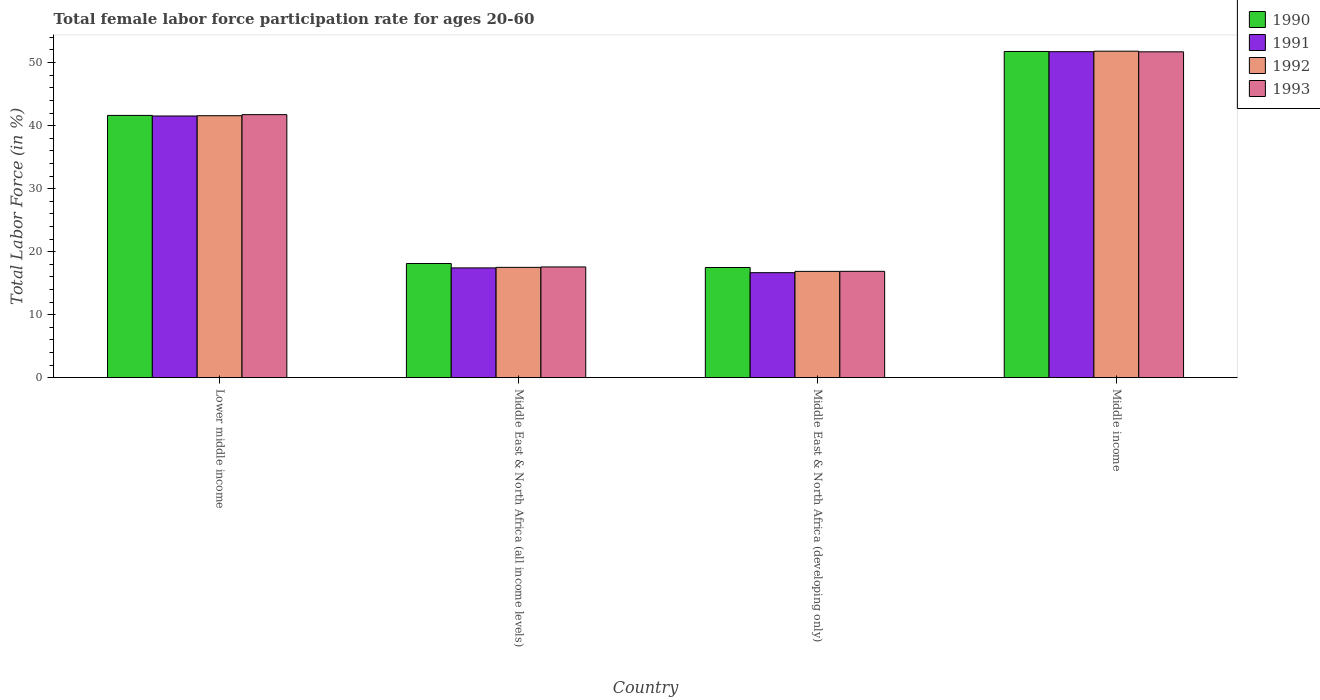How many different coloured bars are there?
Your answer should be very brief. 4. Are the number of bars per tick equal to the number of legend labels?
Give a very brief answer. Yes. How many bars are there on the 1st tick from the left?
Provide a succinct answer. 4. What is the label of the 3rd group of bars from the left?
Offer a very short reply. Middle East & North Africa (developing only). In how many cases, is the number of bars for a given country not equal to the number of legend labels?
Your response must be concise. 0. What is the female labor force participation rate in 1993 in Middle East & North Africa (all income levels)?
Your response must be concise. 17.57. Across all countries, what is the maximum female labor force participation rate in 1993?
Your answer should be compact. 51.71. Across all countries, what is the minimum female labor force participation rate in 1991?
Your response must be concise. 16.66. In which country was the female labor force participation rate in 1993 maximum?
Offer a terse response. Middle income. In which country was the female labor force participation rate in 1993 minimum?
Offer a terse response. Middle East & North Africa (developing only). What is the total female labor force participation rate in 1990 in the graph?
Offer a very short reply. 128.98. What is the difference between the female labor force participation rate in 1991 in Lower middle income and that in Middle East & North Africa (developing only)?
Your answer should be very brief. 24.87. What is the difference between the female labor force participation rate in 1992 in Middle East & North Africa (all income levels) and the female labor force participation rate in 1990 in Middle income?
Keep it short and to the point. -34.26. What is the average female labor force participation rate in 1993 per country?
Offer a terse response. 31.97. What is the difference between the female labor force participation rate of/in 1991 and female labor force participation rate of/in 1992 in Middle East & North Africa (developing only)?
Your response must be concise. -0.21. What is the ratio of the female labor force participation rate in 1993 in Middle East & North Africa (all income levels) to that in Middle income?
Ensure brevity in your answer.  0.34. Is the difference between the female labor force participation rate in 1991 in Middle East & North Africa (developing only) and Middle income greater than the difference between the female labor force participation rate in 1992 in Middle East & North Africa (developing only) and Middle income?
Your answer should be very brief. No. What is the difference between the highest and the second highest female labor force participation rate in 1990?
Give a very brief answer. 23.5. What is the difference between the highest and the lowest female labor force participation rate in 1991?
Keep it short and to the point. 35.07. Is the sum of the female labor force participation rate in 1990 in Lower middle income and Middle East & North Africa (all income levels) greater than the maximum female labor force participation rate in 1992 across all countries?
Give a very brief answer. Yes. What does the 1st bar from the right in Lower middle income represents?
Your answer should be very brief. 1993. Is it the case that in every country, the sum of the female labor force participation rate in 1991 and female labor force participation rate in 1993 is greater than the female labor force participation rate in 1992?
Provide a short and direct response. Yes. Are all the bars in the graph horizontal?
Your answer should be compact. No. What is the difference between two consecutive major ticks on the Y-axis?
Ensure brevity in your answer.  10. Does the graph contain grids?
Offer a very short reply. No. Where does the legend appear in the graph?
Provide a succinct answer. Top right. How are the legend labels stacked?
Keep it short and to the point. Vertical. What is the title of the graph?
Ensure brevity in your answer.  Total female labor force participation rate for ages 20-60. What is the label or title of the X-axis?
Make the answer very short. Country. What is the Total Labor Force (in %) of 1990 in Lower middle income?
Make the answer very short. 41.62. What is the Total Labor Force (in %) in 1991 in Lower middle income?
Give a very brief answer. 41.53. What is the Total Labor Force (in %) in 1992 in Lower middle income?
Keep it short and to the point. 41.57. What is the Total Labor Force (in %) of 1993 in Lower middle income?
Keep it short and to the point. 41.74. What is the Total Labor Force (in %) of 1990 in Middle East & North Africa (all income levels)?
Your response must be concise. 18.11. What is the Total Labor Force (in %) in 1991 in Middle East & North Africa (all income levels)?
Provide a short and direct response. 17.42. What is the Total Labor Force (in %) in 1992 in Middle East & North Africa (all income levels)?
Offer a terse response. 17.5. What is the Total Labor Force (in %) in 1993 in Middle East & North Africa (all income levels)?
Keep it short and to the point. 17.57. What is the Total Labor Force (in %) in 1990 in Middle East & North Africa (developing only)?
Offer a terse response. 17.48. What is the Total Labor Force (in %) of 1991 in Middle East & North Africa (developing only)?
Make the answer very short. 16.66. What is the Total Labor Force (in %) of 1992 in Middle East & North Africa (developing only)?
Provide a short and direct response. 16.87. What is the Total Labor Force (in %) of 1993 in Middle East & North Africa (developing only)?
Provide a short and direct response. 16.88. What is the Total Labor Force (in %) in 1990 in Middle income?
Your response must be concise. 51.76. What is the Total Labor Force (in %) in 1991 in Middle income?
Provide a succinct answer. 51.73. What is the Total Labor Force (in %) of 1992 in Middle income?
Your answer should be compact. 51.81. What is the Total Labor Force (in %) in 1993 in Middle income?
Provide a short and direct response. 51.71. Across all countries, what is the maximum Total Labor Force (in %) in 1990?
Make the answer very short. 51.76. Across all countries, what is the maximum Total Labor Force (in %) of 1991?
Make the answer very short. 51.73. Across all countries, what is the maximum Total Labor Force (in %) in 1992?
Your answer should be compact. 51.81. Across all countries, what is the maximum Total Labor Force (in %) of 1993?
Provide a short and direct response. 51.71. Across all countries, what is the minimum Total Labor Force (in %) of 1990?
Your response must be concise. 17.48. Across all countries, what is the minimum Total Labor Force (in %) of 1991?
Your answer should be very brief. 16.66. Across all countries, what is the minimum Total Labor Force (in %) of 1992?
Offer a very short reply. 16.87. Across all countries, what is the minimum Total Labor Force (in %) of 1993?
Provide a short and direct response. 16.88. What is the total Total Labor Force (in %) of 1990 in the graph?
Offer a terse response. 128.98. What is the total Total Labor Force (in %) in 1991 in the graph?
Keep it short and to the point. 127.34. What is the total Total Labor Force (in %) in 1992 in the graph?
Give a very brief answer. 127.75. What is the total Total Labor Force (in %) of 1993 in the graph?
Give a very brief answer. 127.9. What is the difference between the Total Labor Force (in %) of 1990 in Lower middle income and that in Middle East & North Africa (all income levels)?
Offer a very short reply. 23.5. What is the difference between the Total Labor Force (in %) of 1991 in Lower middle income and that in Middle East & North Africa (all income levels)?
Provide a succinct answer. 24.11. What is the difference between the Total Labor Force (in %) of 1992 in Lower middle income and that in Middle East & North Africa (all income levels)?
Offer a very short reply. 24.07. What is the difference between the Total Labor Force (in %) in 1993 in Lower middle income and that in Middle East & North Africa (all income levels)?
Provide a succinct answer. 24.17. What is the difference between the Total Labor Force (in %) of 1990 in Lower middle income and that in Middle East & North Africa (developing only)?
Make the answer very short. 24.14. What is the difference between the Total Labor Force (in %) in 1991 in Lower middle income and that in Middle East & North Africa (developing only)?
Provide a succinct answer. 24.87. What is the difference between the Total Labor Force (in %) of 1992 in Lower middle income and that in Middle East & North Africa (developing only)?
Make the answer very short. 24.7. What is the difference between the Total Labor Force (in %) in 1993 in Lower middle income and that in Middle East & North Africa (developing only)?
Your answer should be compact. 24.86. What is the difference between the Total Labor Force (in %) in 1990 in Lower middle income and that in Middle income?
Make the answer very short. -10.15. What is the difference between the Total Labor Force (in %) in 1991 in Lower middle income and that in Middle income?
Your answer should be very brief. -10.21. What is the difference between the Total Labor Force (in %) in 1992 in Lower middle income and that in Middle income?
Your answer should be very brief. -10.24. What is the difference between the Total Labor Force (in %) in 1993 in Lower middle income and that in Middle income?
Offer a terse response. -9.97. What is the difference between the Total Labor Force (in %) in 1990 in Middle East & North Africa (all income levels) and that in Middle East & North Africa (developing only)?
Your response must be concise. 0.63. What is the difference between the Total Labor Force (in %) of 1991 in Middle East & North Africa (all income levels) and that in Middle East & North Africa (developing only)?
Provide a short and direct response. 0.76. What is the difference between the Total Labor Force (in %) of 1992 in Middle East & North Africa (all income levels) and that in Middle East & North Africa (developing only)?
Your answer should be very brief. 0.64. What is the difference between the Total Labor Force (in %) in 1993 in Middle East & North Africa (all income levels) and that in Middle East & North Africa (developing only)?
Offer a terse response. 0.69. What is the difference between the Total Labor Force (in %) in 1990 in Middle East & North Africa (all income levels) and that in Middle income?
Ensure brevity in your answer.  -33.65. What is the difference between the Total Labor Force (in %) of 1991 in Middle East & North Africa (all income levels) and that in Middle income?
Your answer should be compact. -34.31. What is the difference between the Total Labor Force (in %) in 1992 in Middle East & North Africa (all income levels) and that in Middle income?
Ensure brevity in your answer.  -34.31. What is the difference between the Total Labor Force (in %) in 1993 in Middle East & North Africa (all income levels) and that in Middle income?
Your answer should be very brief. -34.14. What is the difference between the Total Labor Force (in %) of 1990 in Middle East & North Africa (developing only) and that in Middle income?
Keep it short and to the point. -34.28. What is the difference between the Total Labor Force (in %) in 1991 in Middle East & North Africa (developing only) and that in Middle income?
Your answer should be very brief. -35.07. What is the difference between the Total Labor Force (in %) of 1992 in Middle East & North Africa (developing only) and that in Middle income?
Your response must be concise. -34.94. What is the difference between the Total Labor Force (in %) in 1993 in Middle East & North Africa (developing only) and that in Middle income?
Ensure brevity in your answer.  -34.83. What is the difference between the Total Labor Force (in %) of 1990 in Lower middle income and the Total Labor Force (in %) of 1991 in Middle East & North Africa (all income levels)?
Your answer should be compact. 24.2. What is the difference between the Total Labor Force (in %) in 1990 in Lower middle income and the Total Labor Force (in %) in 1992 in Middle East & North Africa (all income levels)?
Your answer should be compact. 24.12. What is the difference between the Total Labor Force (in %) in 1990 in Lower middle income and the Total Labor Force (in %) in 1993 in Middle East & North Africa (all income levels)?
Your response must be concise. 24.05. What is the difference between the Total Labor Force (in %) of 1991 in Lower middle income and the Total Labor Force (in %) of 1992 in Middle East & North Africa (all income levels)?
Give a very brief answer. 24.02. What is the difference between the Total Labor Force (in %) of 1991 in Lower middle income and the Total Labor Force (in %) of 1993 in Middle East & North Africa (all income levels)?
Offer a very short reply. 23.95. What is the difference between the Total Labor Force (in %) of 1992 in Lower middle income and the Total Labor Force (in %) of 1993 in Middle East & North Africa (all income levels)?
Give a very brief answer. 24. What is the difference between the Total Labor Force (in %) of 1990 in Lower middle income and the Total Labor Force (in %) of 1991 in Middle East & North Africa (developing only)?
Your answer should be very brief. 24.96. What is the difference between the Total Labor Force (in %) in 1990 in Lower middle income and the Total Labor Force (in %) in 1992 in Middle East & North Africa (developing only)?
Provide a succinct answer. 24.75. What is the difference between the Total Labor Force (in %) of 1990 in Lower middle income and the Total Labor Force (in %) of 1993 in Middle East & North Africa (developing only)?
Your answer should be compact. 24.74. What is the difference between the Total Labor Force (in %) of 1991 in Lower middle income and the Total Labor Force (in %) of 1992 in Middle East & North Africa (developing only)?
Offer a terse response. 24.66. What is the difference between the Total Labor Force (in %) of 1991 in Lower middle income and the Total Labor Force (in %) of 1993 in Middle East & North Africa (developing only)?
Your answer should be compact. 24.65. What is the difference between the Total Labor Force (in %) of 1992 in Lower middle income and the Total Labor Force (in %) of 1993 in Middle East & North Africa (developing only)?
Keep it short and to the point. 24.69. What is the difference between the Total Labor Force (in %) in 1990 in Lower middle income and the Total Labor Force (in %) in 1991 in Middle income?
Offer a terse response. -10.11. What is the difference between the Total Labor Force (in %) in 1990 in Lower middle income and the Total Labor Force (in %) in 1992 in Middle income?
Offer a terse response. -10.19. What is the difference between the Total Labor Force (in %) of 1990 in Lower middle income and the Total Labor Force (in %) of 1993 in Middle income?
Ensure brevity in your answer.  -10.09. What is the difference between the Total Labor Force (in %) in 1991 in Lower middle income and the Total Labor Force (in %) in 1992 in Middle income?
Ensure brevity in your answer.  -10.28. What is the difference between the Total Labor Force (in %) of 1991 in Lower middle income and the Total Labor Force (in %) of 1993 in Middle income?
Your answer should be very brief. -10.18. What is the difference between the Total Labor Force (in %) in 1992 in Lower middle income and the Total Labor Force (in %) in 1993 in Middle income?
Offer a very short reply. -10.14. What is the difference between the Total Labor Force (in %) of 1990 in Middle East & North Africa (all income levels) and the Total Labor Force (in %) of 1991 in Middle East & North Africa (developing only)?
Provide a succinct answer. 1.45. What is the difference between the Total Labor Force (in %) of 1990 in Middle East & North Africa (all income levels) and the Total Labor Force (in %) of 1992 in Middle East & North Africa (developing only)?
Make the answer very short. 1.25. What is the difference between the Total Labor Force (in %) in 1990 in Middle East & North Africa (all income levels) and the Total Labor Force (in %) in 1993 in Middle East & North Africa (developing only)?
Give a very brief answer. 1.24. What is the difference between the Total Labor Force (in %) in 1991 in Middle East & North Africa (all income levels) and the Total Labor Force (in %) in 1992 in Middle East & North Africa (developing only)?
Offer a terse response. 0.55. What is the difference between the Total Labor Force (in %) of 1991 in Middle East & North Africa (all income levels) and the Total Labor Force (in %) of 1993 in Middle East & North Africa (developing only)?
Offer a terse response. 0.54. What is the difference between the Total Labor Force (in %) of 1992 in Middle East & North Africa (all income levels) and the Total Labor Force (in %) of 1993 in Middle East & North Africa (developing only)?
Make the answer very short. 0.63. What is the difference between the Total Labor Force (in %) in 1990 in Middle East & North Africa (all income levels) and the Total Labor Force (in %) in 1991 in Middle income?
Your answer should be very brief. -33.62. What is the difference between the Total Labor Force (in %) of 1990 in Middle East & North Africa (all income levels) and the Total Labor Force (in %) of 1992 in Middle income?
Keep it short and to the point. -33.7. What is the difference between the Total Labor Force (in %) of 1990 in Middle East & North Africa (all income levels) and the Total Labor Force (in %) of 1993 in Middle income?
Ensure brevity in your answer.  -33.6. What is the difference between the Total Labor Force (in %) of 1991 in Middle East & North Africa (all income levels) and the Total Labor Force (in %) of 1992 in Middle income?
Keep it short and to the point. -34.39. What is the difference between the Total Labor Force (in %) of 1991 in Middle East & North Africa (all income levels) and the Total Labor Force (in %) of 1993 in Middle income?
Your answer should be compact. -34.29. What is the difference between the Total Labor Force (in %) of 1992 in Middle East & North Africa (all income levels) and the Total Labor Force (in %) of 1993 in Middle income?
Your answer should be very brief. -34.21. What is the difference between the Total Labor Force (in %) in 1990 in Middle East & North Africa (developing only) and the Total Labor Force (in %) in 1991 in Middle income?
Your response must be concise. -34.25. What is the difference between the Total Labor Force (in %) in 1990 in Middle East & North Africa (developing only) and the Total Labor Force (in %) in 1992 in Middle income?
Your answer should be very brief. -34.33. What is the difference between the Total Labor Force (in %) in 1990 in Middle East & North Africa (developing only) and the Total Labor Force (in %) in 1993 in Middle income?
Your answer should be compact. -34.23. What is the difference between the Total Labor Force (in %) of 1991 in Middle East & North Africa (developing only) and the Total Labor Force (in %) of 1992 in Middle income?
Offer a very short reply. -35.15. What is the difference between the Total Labor Force (in %) in 1991 in Middle East & North Africa (developing only) and the Total Labor Force (in %) in 1993 in Middle income?
Provide a short and direct response. -35.05. What is the difference between the Total Labor Force (in %) in 1992 in Middle East & North Africa (developing only) and the Total Labor Force (in %) in 1993 in Middle income?
Your response must be concise. -34.84. What is the average Total Labor Force (in %) in 1990 per country?
Ensure brevity in your answer.  32.24. What is the average Total Labor Force (in %) of 1991 per country?
Offer a very short reply. 31.83. What is the average Total Labor Force (in %) of 1992 per country?
Provide a succinct answer. 31.94. What is the average Total Labor Force (in %) in 1993 per country?
Your answer should be very brief. 31.97. What is the difference between the Total Labor Force (in %) in 1990 and Total Labor Force (in %) in 1991 in Lower middle income?
Your response must be concise. 0.09. What is the difference between the Total Labor Force (in %) of 1990 and Total Labor Force (in %) of 1992 in Lower middle income?
Keep it short and to the point. 0.05. What is the difference between the Total Labor Force (in %) in 1990 and Total Labor Force (in %) in 1993 in Lower middle income?
Give a very brief answer. -0.12. What is the difference between the Total Labor Force (in %) of 1991 and Total Labor Force (in %) of 1992 in Lower middle income?
Ensure brevity in your answer.  -0.04. What is the difference between the Total Labor Force (in %) in 1991 and Total Labor Force (in %) in 1993 in Lower middle income?
Your answer should be very brief. -0.21. What is the difference between the Total Labor Force (in %) in 1992 and Total Labor Force (in %) in 1993 in Lower middle income?
Your answer should be very brief. -0.17. What is the difference between the Total Labor Force (in %) of 1990 and Total Labor Force (in %) of 1991 in Middle East & North Africa (all income levels)?
Provide a succinct answer. 0.69. What is the difference between the Total Labor Force (in %) in 1990 and Total Labor Force (in %) in 1992 in Middle East & North Africa (all income levels)?
Give a very brief answer. 0.61. What is the difference between the Total Labor Force (in %) of 1990 and Total Labor Force (in %) of 1993 in Middle East & North Africa (all income levels)?
Ensure brevity in your answer.  0.54. What is the difference between the Total Labor Force (in %) of 1991 and Total Labor Force (in %) of 1992 in Middle East & North Africa (all income levels)?
Make the answer very short. -0.08. What is the difference between the Total Labor Force (in %) of 1991 and Total Labor Force (in %) of 1993 in Middle East & North Africa (all income levels)?
Give a very brief answer. -0.15. What is the difference between the Total Labor Force (in %) of 1992 and Total Labor Force (in %) of 1993 in Middle East & North Africa (all income levels)?
Ensure brevity in your answer.  -0.07. What is the difference between the Total Labor Force (in %) in 1990 and Total Labor Force (in %) in 1991 in Middle East & North Africa (developing only)?
Your answer should be compact. 0.82. What is the difference between the Total Labor Force (in %) in 1990 and Total Labor Force (in %) in 1992 in Middle East & North Africa (developing only)?
Your answer should be compact. 0.62. What is the difference between the Total Labor Force (in %) of 1990 and Total Labor Force (in %) of 1993 in Middle East & North Africa (developing only)?
Your response must be concise. 0.61. What is the difference between the Total Labor Force (in %) of 1991 and Total Labor Force (in %) of 1992 in Middle East & North Africa (developing only)?
Provide a short and direct response. -0.21. What is the difference between the Total Labor Force (in %) in 1991 and Total Labor Force (in %) in 1993 in Middle East & North Africa (developing only)?
Keep it short and to the point. -0.22. What is the difference between the Total Labor Force (in %) of 1992 and Total Labor Force (in %) of 1993 in Middle East & North Africa (developing only)?
Provide a succinct answer. -0.01. What is the difference between the Total Labor Force (in %) of 1990 and Total Labor Force (in %) of 1991 in Middle income?
Your response must be concise. 0.03. What is the difference between the Total Labor Force (in %) in 1990 and Total Labor Force (in %) in 1992 in Middle income?
Keep it short and to the point. -0.05. What is the difference between the Total Labor Force (in %) of 1990 and Total Labor Force (in %) of 1993 in Middle income?
Your answer should be compact. 0.05. What is the difference between the Total Labor Force (in %) of 1991 and Total Labor Force (in %) of 1992 in Middle income?
Provide a succinct answer. -0.08. What is the difference between the Total Labor Force (in %) of 1991 and Total Labor Force (in %) of 1993 in Middle income?
Your response must be concise. 0.02. What is the difference between the Total Labor Force (in %) in 1992 and Total Labor Force (in %) in 1993 in Middle income?
Your response must be concise. 0.1. What is the ratio of the Total Labor Force (in %) in 1990 in Lower middle income to that in Middle East & North Africa (all income levels)?
Your answer should be compact. 2.3. What is the ratio of the Total Labor Force (in %) in 1991 in Lower middle income to that in Middle East & North Africa (all income levels)?
Provide a succinct answer. 2.38. What is the ratio of the Total Labor Force (in %) in 1992 in Lower middle income to that in Middle East & North Africa (all income levels)?
Make the answer very short. 2.38. What is the ratio of the Total Labor Force (in %) of 1993 in Lower middle income to that in Middle East & North Africa (all income levels)?
Offer a very short reply. 2.38. What is the ratio of the Total Labor Force (in %) of 1990 in Lower middle income to that in Middle East & North Africa (developing only)?
Give a very brief answer. 2.38. What is the ratio of the Total Labor Force (in %) in 1991 in Lower middle income to that in Middle East & North Africa (developing only)?
Your answer should be very brief. 2.49. What is the ratio of the Total Labor Force (in %) in 1992 in Lower middle income to that in Middle East & North Africa (developing only)?
Offer a very short reply. 2.46. What is the ratio of the Total Labor Force (in %) in 1993 in Lower middle income to that in Middle East & North Africa (developing only)?
Your response must be concise. 2.47. What is the ratio of the Total Labor Force (in %) in 1990 in Lower middle income to that in Middle income?
Offer a terse response. 0.8. What is the ratio of the Total Labor Force (in %) in 1991 in Lower middle income to that in Middle income?
Your answer should be very brief. 0.8. What is the ratio of the Total Labor Force (in %) in 1992 in Lower middle income to that in Middle income?
Ensure brevity in your answer.  0.8. What is the ratio of the Total Labor Force (in %) in 1993 in Lower middle income to that in Middle income?
Offer a terse response. 0.81. What is the ratio of the Total Labor Force (in %) in 1990 in Middle East & North Africa (all income levels) to that in Middle East & North Africa (developing only)?
Make the answer very short. 1.04. What is the ratio of the Total Labor Force (in %) in 1991 in Middle East & North Africa (all income levels) to that in Middle East & North Africa (developing only)?
Your response must be concise. 1.05. What is the ratio of the Total Labor Force (in %) of 1992 in Middle East & North Africa (all income levels) to that in Middle East & North Africa (developing only)?
Provide a succinct answer. 1.04. What is the ratio of the Total Labor Force (in %) in 1993 in Middle East & North Africa (all income levels) to that in Middle East & North Africa (developing only)?
Keep it short and to the point. 1.04. What is the ratio of the Total Labor Force (in %) of 1990 in Middle East & North Africa (all income levels) to that in Middle income?
Give a very brief answer. 0.35. What is the ratio of the Total Labor Force (in %) of 1991 in Middle East & North Africa (all income levels) to that in Middle income?
Your answer should be very brief. 0.34. What is the ratio of the Total Labor Force (in %) in 1992 in Middle East & North Africa (all income levels) to that in Middle income?
Your answer should be compact. 0.34. What is the ratio of the Total Labor Force (in %) in 1993 in Middle East & North Africa (all income levels) to that in Middle income?
Offer a very short reply. 0.34. What is the ratio of the Total Labor Force (in %) of 1990 in Middle East & North Africa (developing only) to that in Middle income?
Provide a succinct answer. 0.34. What is the ratio of the Total Labor Force (in %) of 1991 in Middle East & North Africa (developing only) to that in Middle income?
Your response must be concise. 0.32. What is the ratio of the Total Labor Force (in %) of 1992 in Middle East & North Africa (developing only) to that in Middle income?
Give a very brief answer. 0.33. What is the ratio of the Total Labor Force (in %) in 1993 in Middle East & North Africa (developing only) to that in Middle income?
Your answer should be very brief. 0.33. What is the difference between the highest and the second highest Total Labor Force (in %) of 1990?
Your answer should be compact. 10.15. What is the difference between the highest and the second highest Total Labor Force (in %) in 1991?
Your answer should be very brief. 10.21. What is the difference between the highest and the second highest Total Labor Force (in %) of 1992?
Your answer should be compact. 10.24. What is the difference between the highest and the second highest Total Labor Force (in %) of 1993?
Offer a terse response. 9.97. What is the difference between the highest and the lowest Total Labor Force (in %) of 1990?
Keep it short and to the point. 34.28. What is the difference between the highest and the lowest Total Labor Force (in %) in 1991?
Your answer should be compact. 35.07. What is the difference between the highest and the lowest Total Labor Force (in %) in 1992?
Provide a succinct answer. 34.94. What is the difference between the highest and the lowest Total Labor Force (in %) of 1993?
Offer a very short reply. 34.83. 